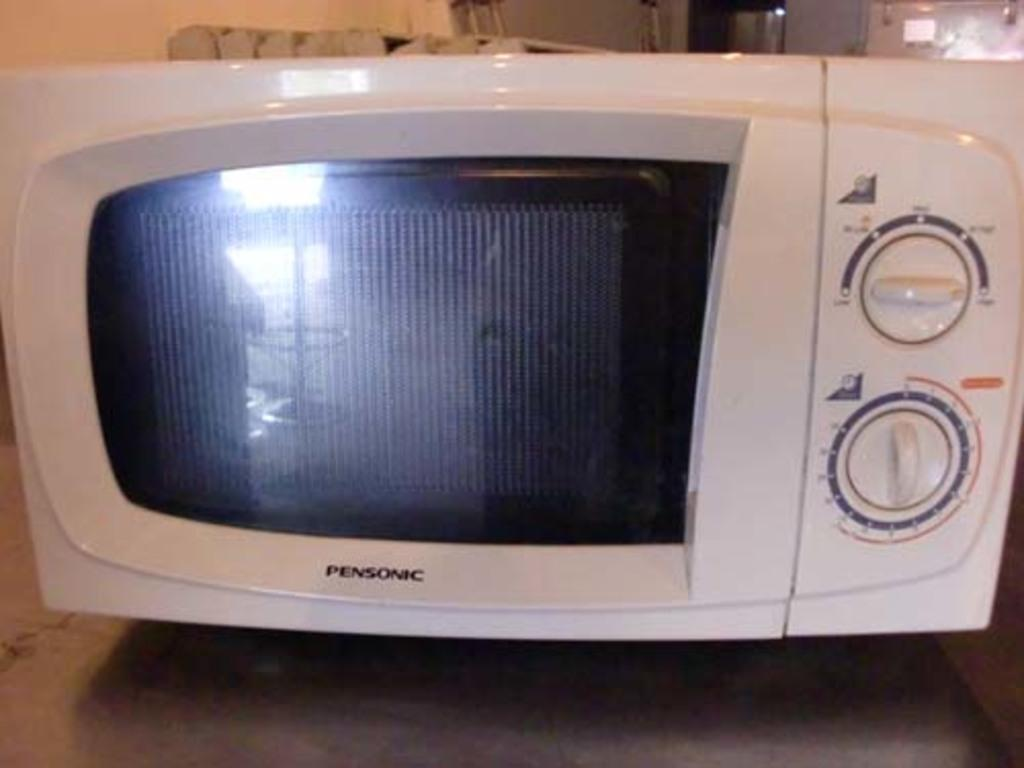<image>
Offer a succinct explanation of the picture presented. an appliance that has Pensonic written on it 